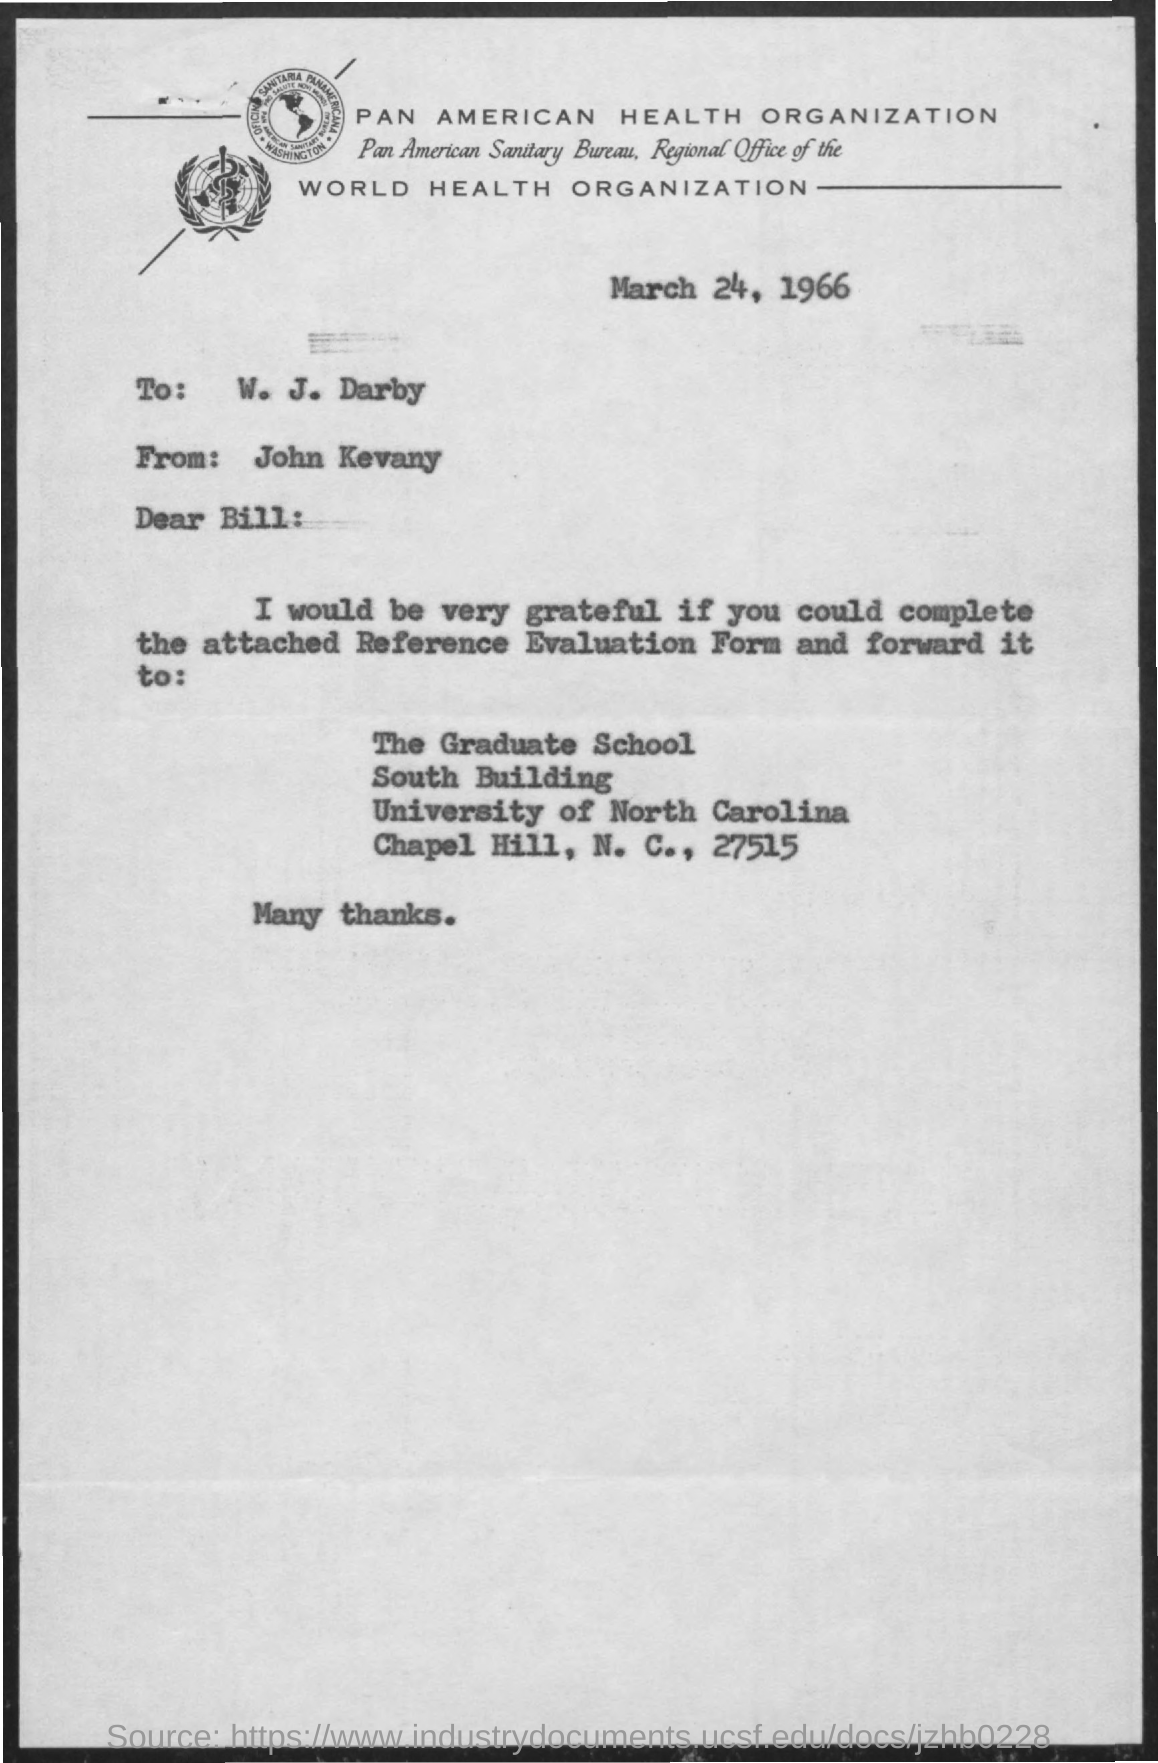When is the document dated?
Ensure brevity in your answer.  March 24, 1966. To whom is the letter addressed?
Your answer should be very brief. W. j. darby. From whom is the letter?
Offer a very short reply. John Kevany. Which form should be filled and forwarded?
Provide a short and direct response. Reference Evaluation Form. 